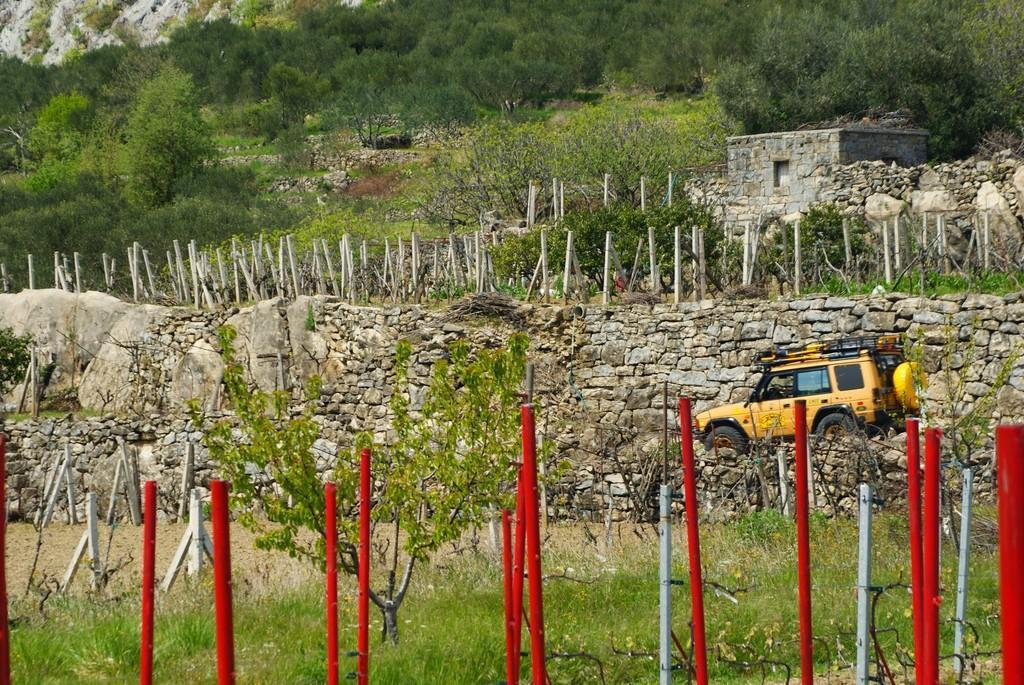How would you summarize this image in a sentence or two? This is an outside view. At the bottom there are some poles and I can see the grass on the ground. On the right side there is a vehicle. In the background there are many trees, poles and also there is a house. In the middle of the image there is a wall. 